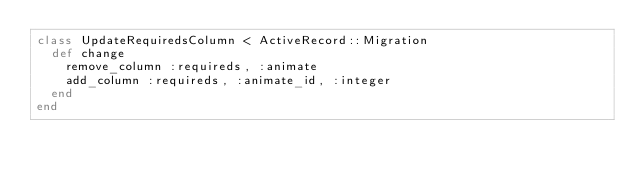Convert code to text. <code><loc_0><loc_0><loc_500><loc_500><_Ruby_>class UpdateRequiredsColumn < ActiveRecord::Migration
  def change
    remove_column :requireds, :animate
    add_column :requireds, :animate_id, :integer
  end
end
</code> 